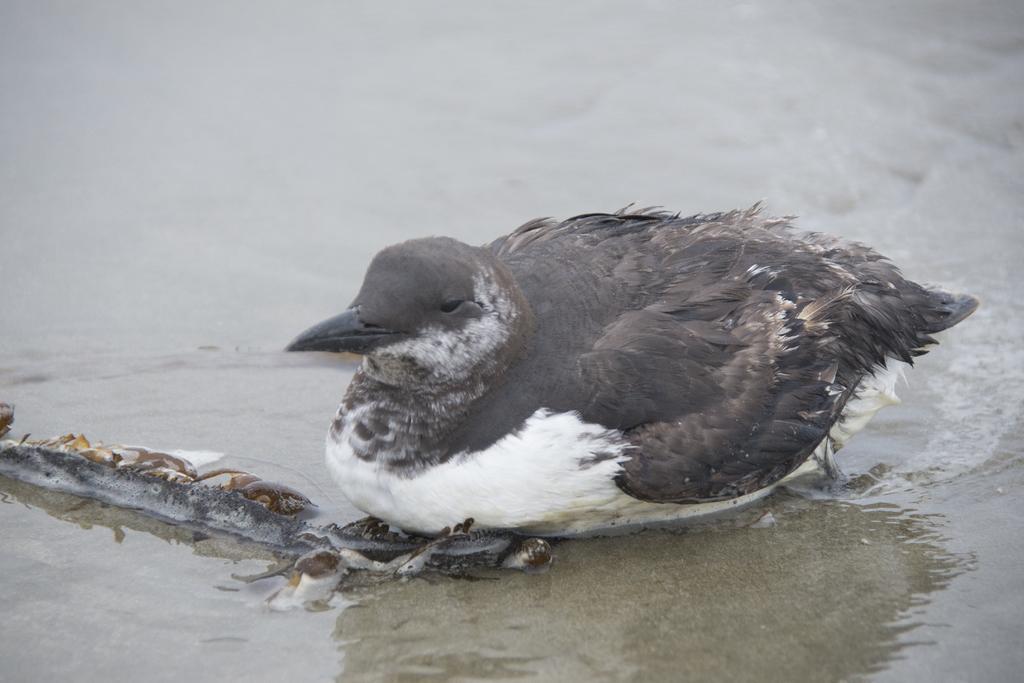Please provide a concise description of this image. In the center of the picture there is a bird. On the left there is an object. At the bottom there is sand. On the right there is water. 